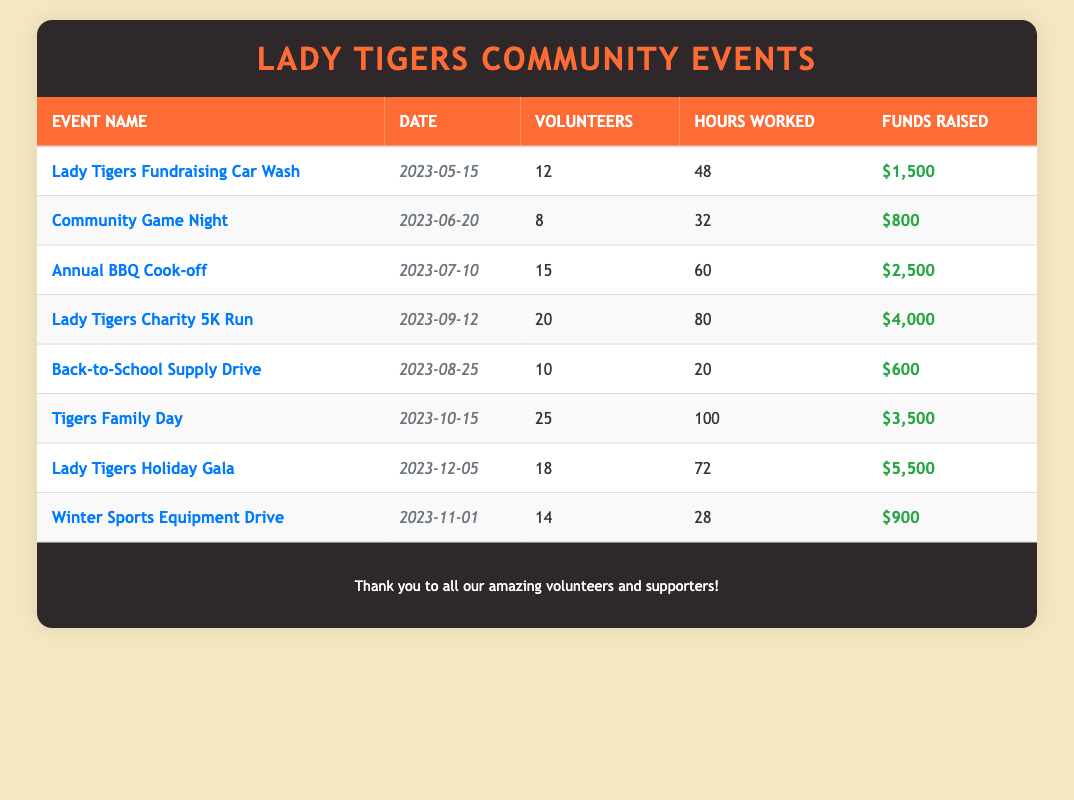What is the event that raised the most funds? The table shows the funds raised for each event. By checking each event, the "Lady Tigers Holiday Gala" raised the most funds at $5,500.
Answer: Lady Tigers Holiday Gala How many volunteers participated in the "Lady Tigers Charity 5K Run"? The table directly states that 20 volunteers participated in the "Lady Tigers Charity 5K Run".
Answer: 20 What is the total number of hours worked by volunteers across all events? To find the total hours worked, add the hours for each event: 48 + 32 + 60 + 80 + 20 + 100 + 72 + 28 = 440.
Answer: 440 Was there any event that had less than 10 volunteers? By examining the table, the "Community Game Night" had only 8 volunteers.
Answer: Yes What was the average funds raised per event? There are 8 events with the following funds raised: 1500, 800, 2500, 4000, 600, 3500, 5500, 900. The total is 1500 + 800 + 2500 + 4000 + 600 + 3500 + 5500 + 900 = 14700. Divide by 8 gives an average of 1837.5.
Answer: 1837.5 Which event took place last in the year? The table lists the events in chronological order. The last event is the "Lady Tigers Holiday Gala" on December 5, 2023.
Answer: Lady Tigers Holiday Gala How many more volunteers participated in "Tigers Family Day" than in "Winter Sports Equipment Drive"? The "Tigers Family Day" had 25 volunteers while the "Winter Sports Equipment Drive" had 14. The difference is 25 - 14 = 11.
Answer: 11 What is the total money raised from the "Back-to-School Supply Drive" and "Community Game Night"? The funds raised for "Back-to-School Supply Drive" is $600 and for "Community Game Night" it is $800. Adding these gives 600 + 800 = 1400.
Answer: 1400 Did the "Annual BBQ Cook-off" have more hours worked than the "Winter Sports Equipment Drive"? The "Annual BBQ Cook-off" had 60 hours worked while the "Winter Sports Equipment Drive" had 28 hours. Since 60 > 28, the statement is true.
Answer: Yes What is the total number of volunteers for events that raised over $3000? The events that raised over $3000 are the "Lady Tigers Charity 5K Run" (20 volunteers), "Tigers Family Day" (25 volunteers), and "Lady Tigers Holiday Gala" (18 volunteers). Adding these gives 20 + 25 + 18 = 63.
Answer: 63 How many hours did the "Lady Tigers Fundraising Car Wash" volunteers work compared to the "Community Game Night"? The "Lady Tigers Fundraising Car Wash" had 48 hours worked and the "Community Game Night" had 32 hours. The difference is 48 - 32 = 16.
Answer: 16 